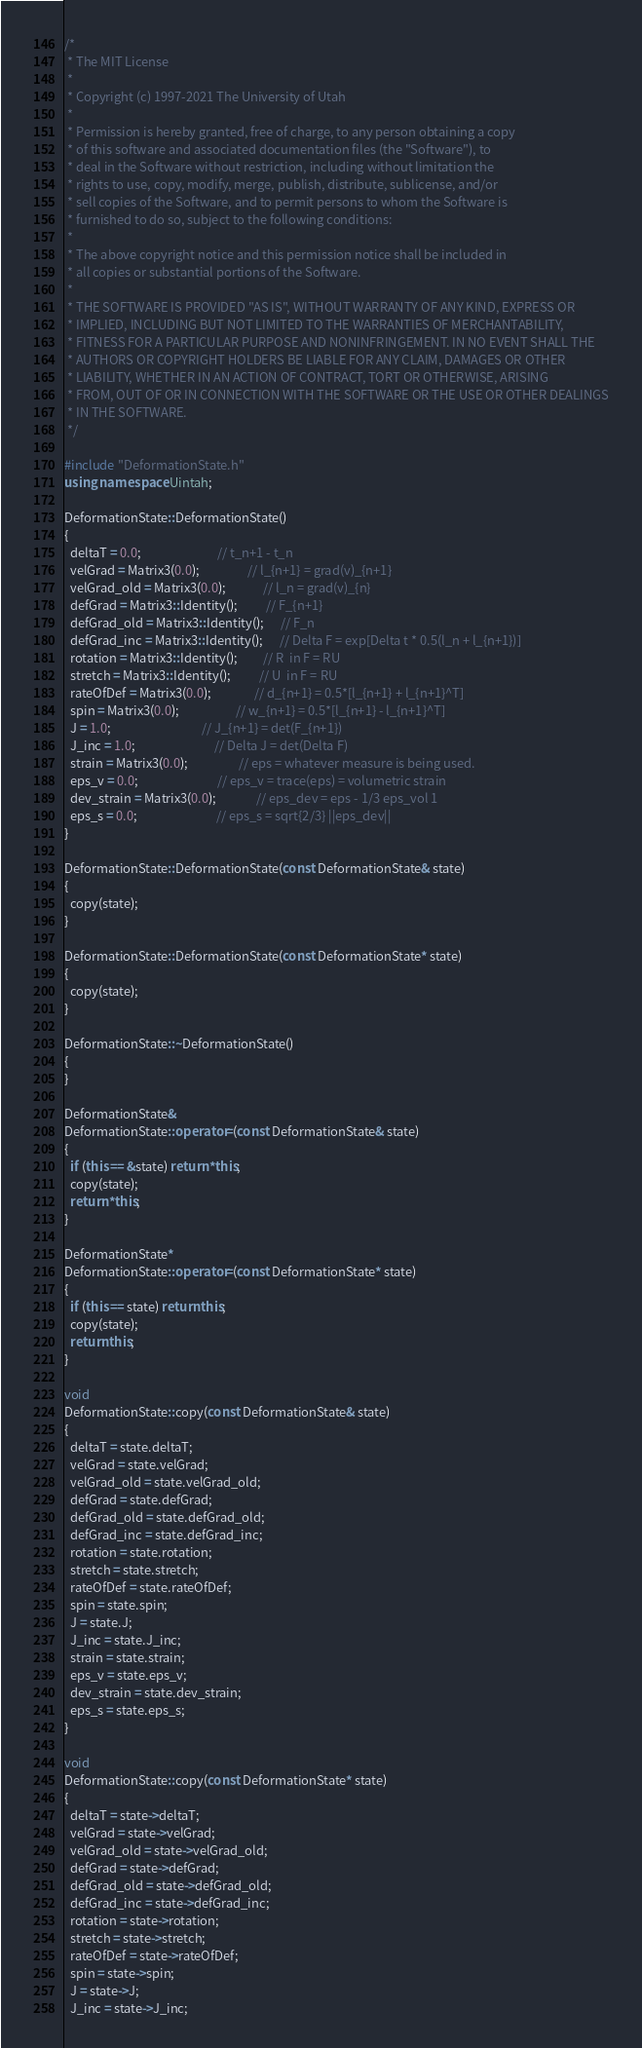Convert code to text. <code><loc_0><loc_0><loc_500><loc_500><_C++_>/*
 * The MIT License
 *
 * Copyright (c) 1997-2021 The University of Utah
 *
 * Permission is hereby granted, free of charge, to any person obtaining a copy
 * of this software and associated documentation files (the "Software"), to
 * deal in the Software without restriction, including without limitation the
 * rights to use, copy, modify, merge, publish, distribute, sublicense, and/or
 * sell copies of the Software, and to permit persons to whom the Software is
 * furnished to do so, subject to the following conditions:
 *
 * The above copyright notice and this permission notice shall be included in
 * all copies or substantial portions of the Software.
 *
 * THE SOFTWARE IS PROVIDED "AS IS", WITHOUT WARRANTY OF ANY KIND, EXPRESS OR
 * IMPLIED, INCLUDING BUT NOT LIMITED TO THE WARRANTIES OF MERCHANTABILITY,
 * FITNESS FOR A PARTICULAR PURPOSE AND NONINFRINGEMENT. IN NO EVENT SHALL THE
 * AUTHORS OR COPYRIGHT HOLDERS BE LIABLE FOR ANY CLAIM, DAMAGES OR OTHER
 * LIABILITY, WHETHER IN AN ACTION OF CONTRACT, TORT OR OTHERWISE, ARISING
 * FROM, OUT OF OR IN CONNECTION WITH THE SOFTWARE OR THE USE OR OTHER DEALINGS
 * IN THE SOFTWARE.
 */

#include "DeformationState.h"
using namespace Uintah;

DeformationState::DeformationState()
{
  deltaT = 0.0;                           // t_n+1 - t_n
  velGrad = Matrix3(0.0);                 // l_{n+1} = grad(v)_{n+1}
  velGrad_old = Matrix3(0.0);             // l_n = grad(v)_{n}
  defGrad = Matrix3::Identity();          // F_{n+1}
  defGrad_old = Matrix3::Identity();      // F_n
  defGrad_inc = Matrix3::Identity();      // Delta F = exp[Delta t * 0.5(l_n + l_{n+1})]
  rotation = Matrix3::Identity();         // R  in F = RU
  stretch = Matrix3::Identity();          // U  in F = RU
  rateOfDef = Matrix3(0.0);               // d_{n+1} = 0.5*[l_{n+1} + l_{n+1}^T]
  spin = Matrix3(0.0);                    // w_{n+1} = 0.5*[l_{n+1} - l_{n+1}^T]
  J = 1.0;                                // J_{n+1} = det(F_{n+1})
  J_inc = 1.0;                            // Delta J = det(Delta F)
  strain = Matrix3(0.0);                  // eps = whatever measure is being used.
  eps_v = 0.0;                            // eps_v = trace(eps) = volumetric strain
  dev_strain = Matrix3(0.0);              // eps_dev = eps - 1/3 eps_vol 1
  eps_s = 0.0;                            // eps_s = sqrt{2/3} ||eps_dev||
}

DeformationState::DeformationState(const DeformationState& state)
{
  copy(state);
}

DeformationState::DeformationState(const DeformationState* state)
{
  copy(state);
}

DeformationState::~DeformationState()
{
}

DeformationState&
DeformationState::operator=(const DeformationState& state)
{
  if (this == &state) return *this;
  copy(state);
  return *this;
}

DeformationState*
DeformationState::operator=(const DeformationState* state)
{
  if (this == state) return this;
  copy(state);
  return this;
}

void
DeformationState::copy(const DeformationState& state)
{
  deltaT = state.deltaT;
  velGrad = state.velGrad;
  velGrad_old = state.velGrad_old;
  defGrad = state.defGrad;
  defGrad_old = state.defGrad_old;
  defGrad_inc = state.defGrad_inc;
  rotation = state.rotation;
  stretch = state.stretch;
  rateOfDef = state.rateOfDef;
  spin = state.spin;
  J = state.J;
  J_inc = state.J_inc;
  strain = state.strain;
  eps_v = state.eps_v;
  dev_strain = state.dev_strain;
  eps_s = state.eps_s;
}

void
DeformationState::copy(const DeformationState* state)
{
  deltaT = state->deltaT;
  velGrad = state->velGrad;
  velGrad_old = state->velGrad_old;
  defGrad = state->defGrad;
  defGrad_old = state->defGrad_old;
  defGrad_inc = state->defGrad_inc;
  rotation = state->rotation;
  stretch = state->stretch;
  rateOfDef = state->rateOfDef;
  spin = state->spin;
  J = state->J;
  J_inc = state->J_inc;</code> 